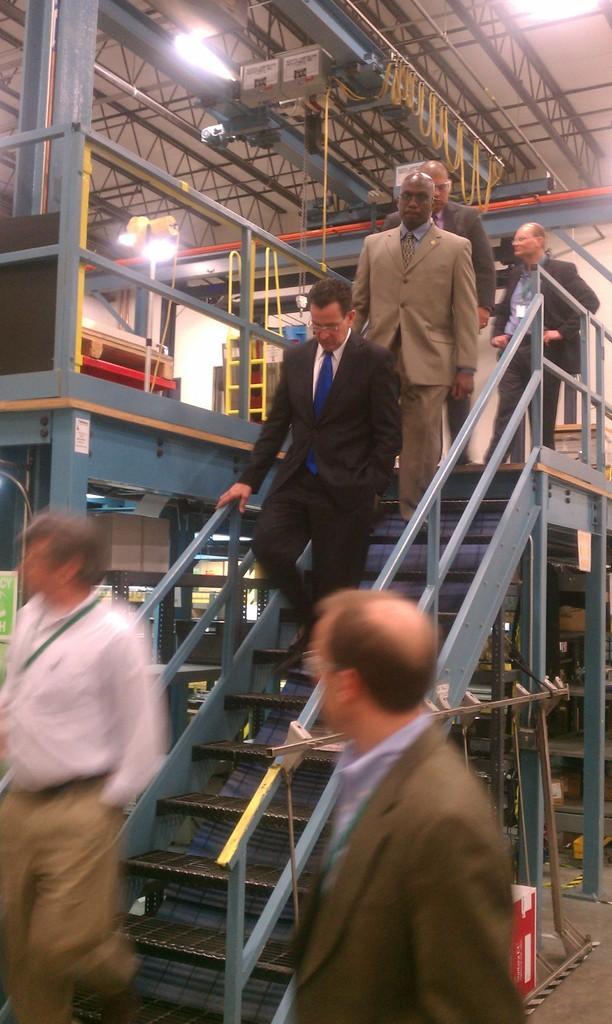Can you describe this image briefly? In this picture we can see there are three people standing and other three people walking on the staircase. Behind the people there are some iron objects, lights, some objects and a wall. 